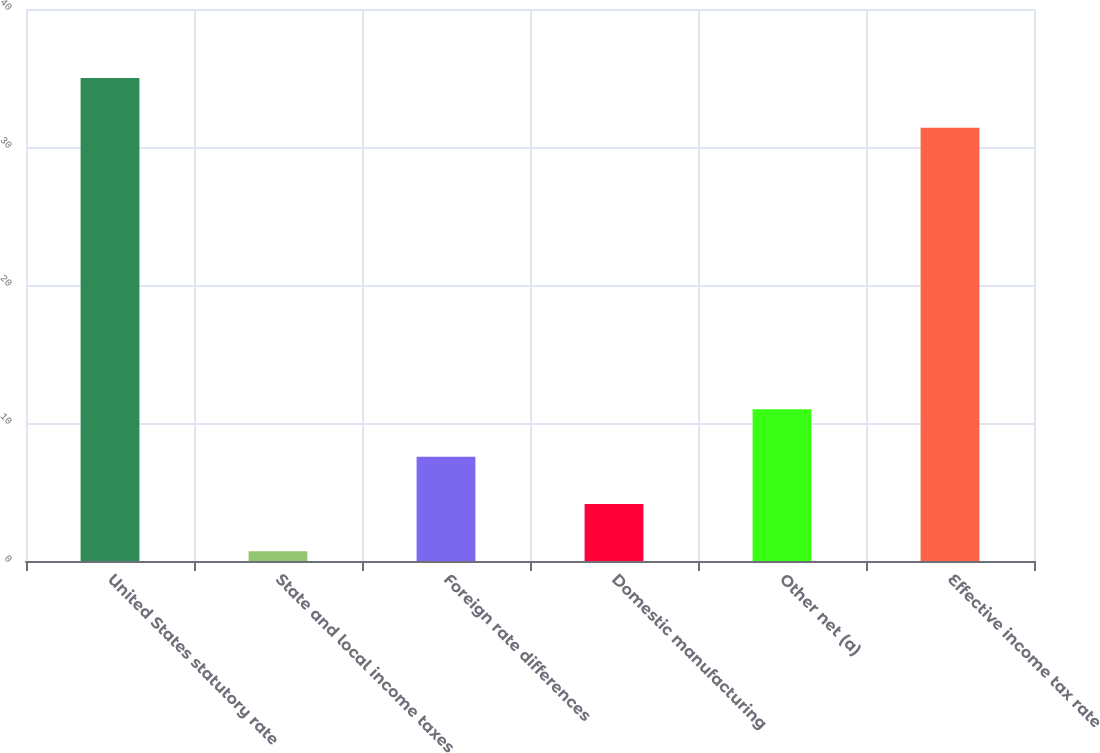Convert chart to OTSL. <chart><loc_0><loc_0><loc_500><loc_500><bar_chart><fcel>United States statutory rate<fcel>State and local income taxes<fcel>Foreign rate differences<fcel>Domestic manufacturing<fcel>Other net (a)<fcel>Effective income tax rate<nl><fcel>35<fcel>0.7<fcel>7.56<fcel>4.13<fcel>10.99<fcel>31.4<nl></chart> 